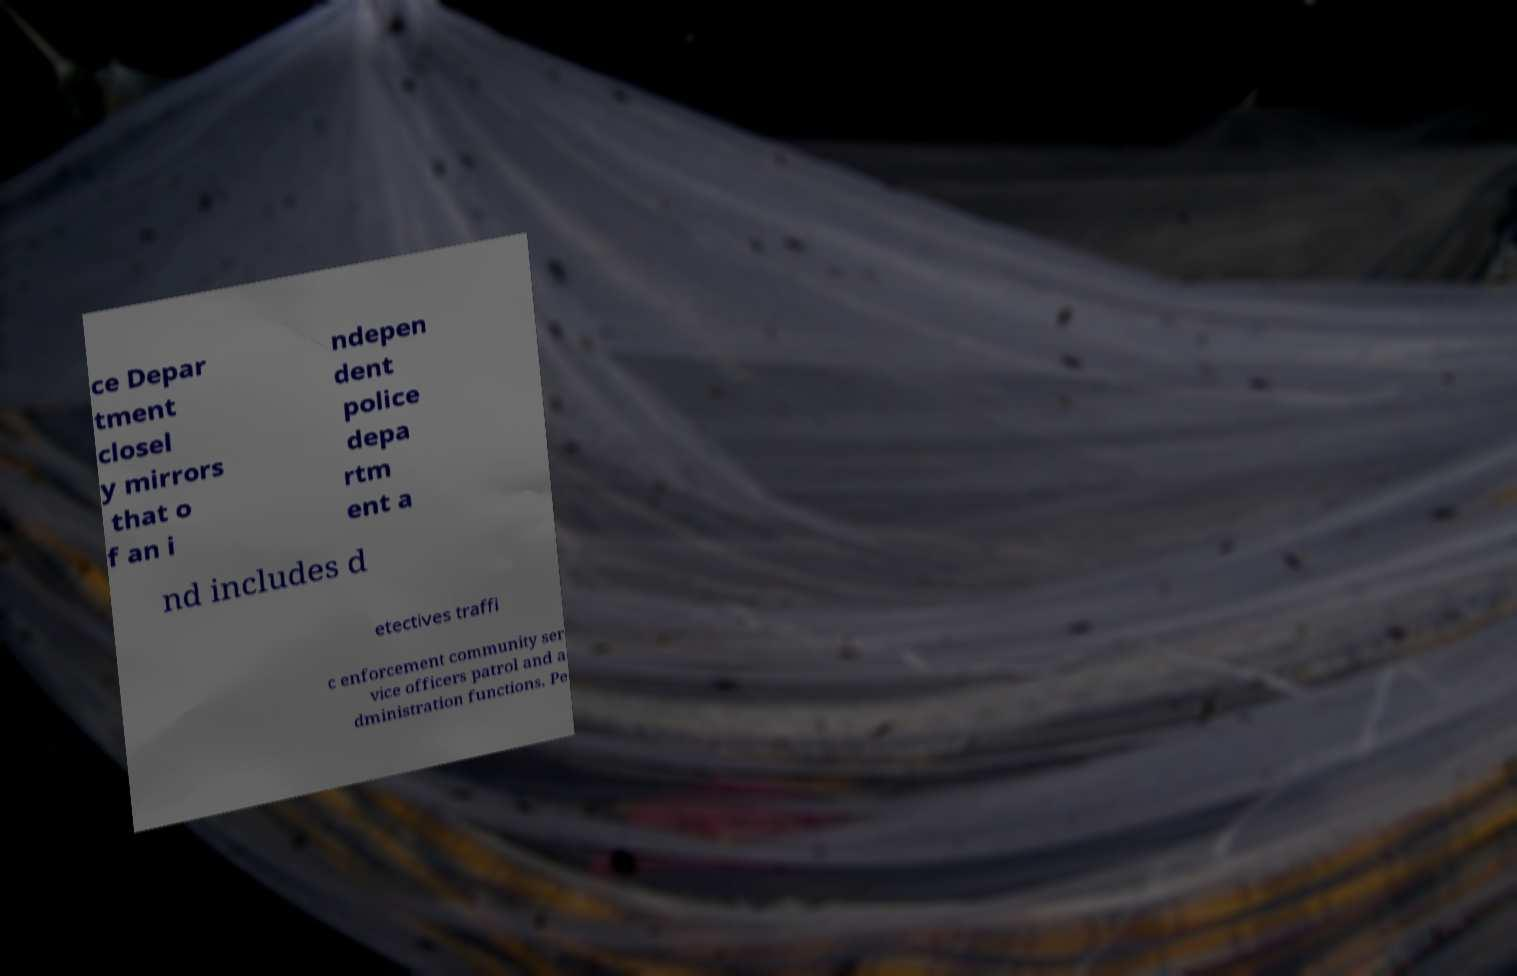Please identify and transcribe the text found in this image. ce Depar tment closel y mirrors that o f an i ndepen dent police depa rtm ent a nd includes d etectives traffi c enforcement community ser vice officers patrol and a dministration functions. Pe 